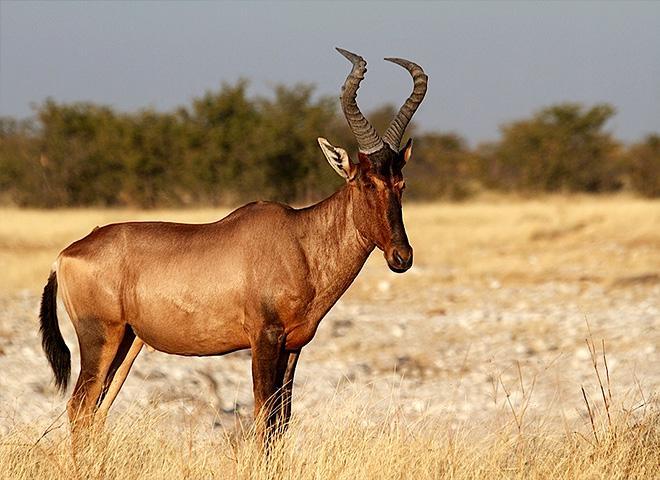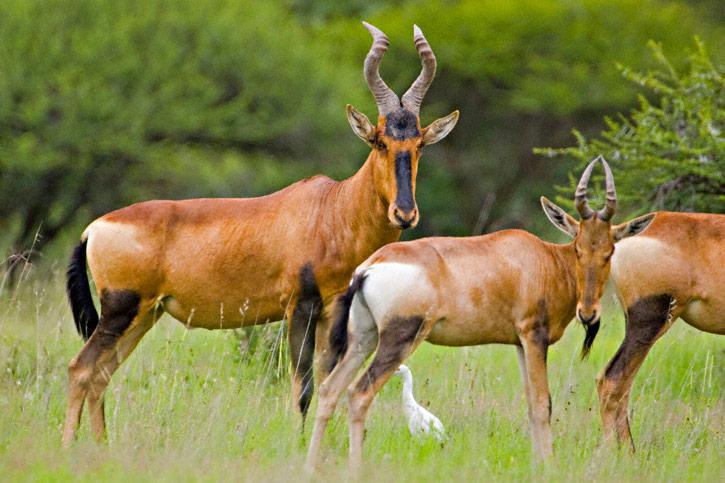The first image is the image on the left, the second image is the image on the right. Analyze the images presented: Is the assertion "A hunter in camo is posed behind a downed long-horned animal, with his weapon propped against the animal's front." valid? Answer yes or no. No. The first image is the image on the left, the second image is the image on the right. Assess this claim about the two images: "At least one of the images shows a human posing behind a horned animal.". Correct or not? Answer yes or no. No. 